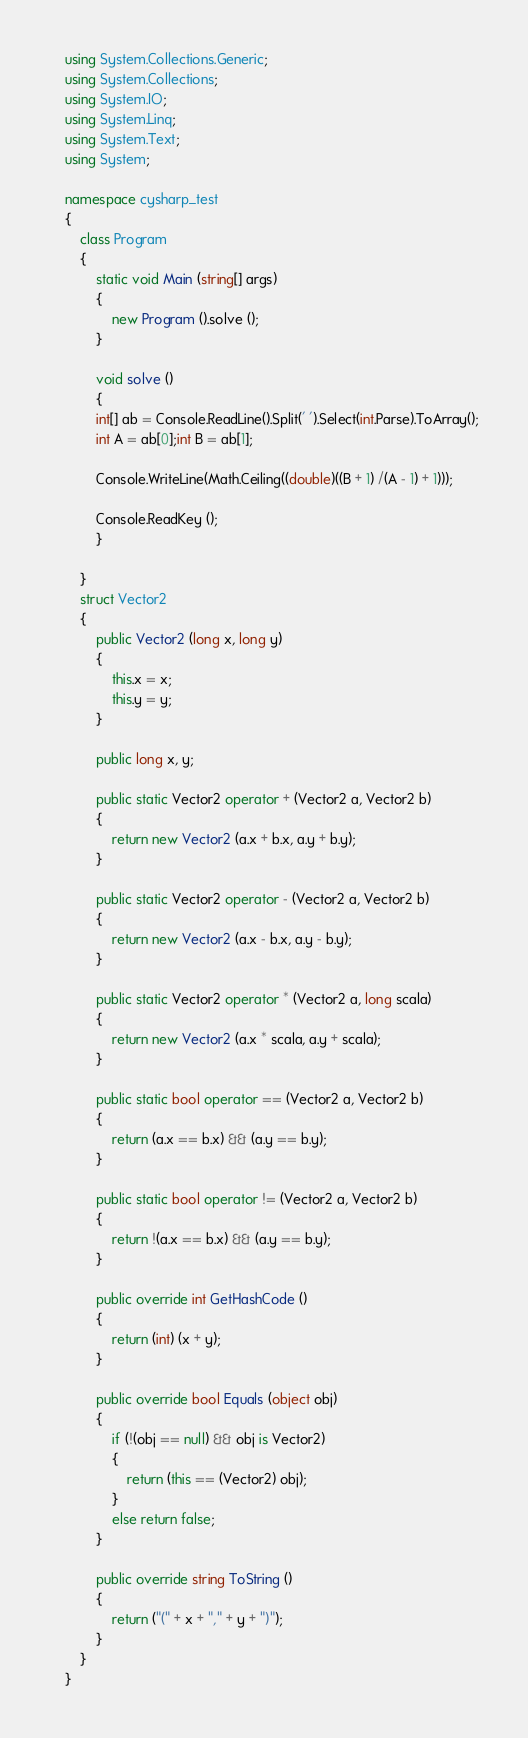<code> <loc_0><loc_0><loc_500><loc_500><_C#_>    using System.Collections.Generic;
    using System.Collections;
    using System.IO;
    using System.Linq;
    using System.Text;
    using System;

    namespace cysharp_test
    {
        class Program
        {
            static void Main (string[] args)
            {
                new Program ().solve ();
            }

            void solve ()
            {
            int[] ab = Console.ReadLine().Split(' ').Select(int.Parse).ToArray();
            int A = ab[0];int B = ab[1];

            Console.WriteLine(Math.Ceiling((double)((B + 1) /(A - 1) + 1)));

            Console.ReadKey ();
            }

        }
        struct Vector2
        {
            public Vector2 (long x, long y)
            {
                this.x = x;
                this.y = y;
            }

            public long x, y;

            public static Vector2 operator + (Vector2 a, Vector2 b)
            {
                return new Vector2 (a.x + b.x, a.y + b.y);
            }

            public static Vector2 operator - (Vector2 a, Vector2 b)
            {
                return new Vector2 (a.x - b.x, a.y - b.y);
            }

            public static Vector2 operator * (Vector2 a, long scala)
            {
                return new Vector2 (a.x * scala, a.y + scala);
            }

            public static bool operator == (Vector2 a, Vector2 b)
            {
                return (a.x == b.x) && (a.y == b.y);
            }

            public static bool operator != (Vector2 a, Vector2 b)
            {
                return !(a.x == b.x) && (a.y == b.y);
            }

            public override int GetHashCode ()
            {
                return (int) (x + y);
            }

            public override bool Equals (object obj)
            {
                if (!(obj == null) && obj is Vector2)
                {
                    return (this == (Vector2) obj);
                }
                else return false;
            }

            public override string ToString ()
            {
                return ("(" + x + "," + y + ")");
            }
        }
    }</code> 